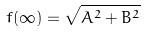<formula> <loc_0><loc_0><loc_500><loc_500>f ( \infty ) = \sqrt { A ^ { 2 } + B ^ { 2 } }</formula> 